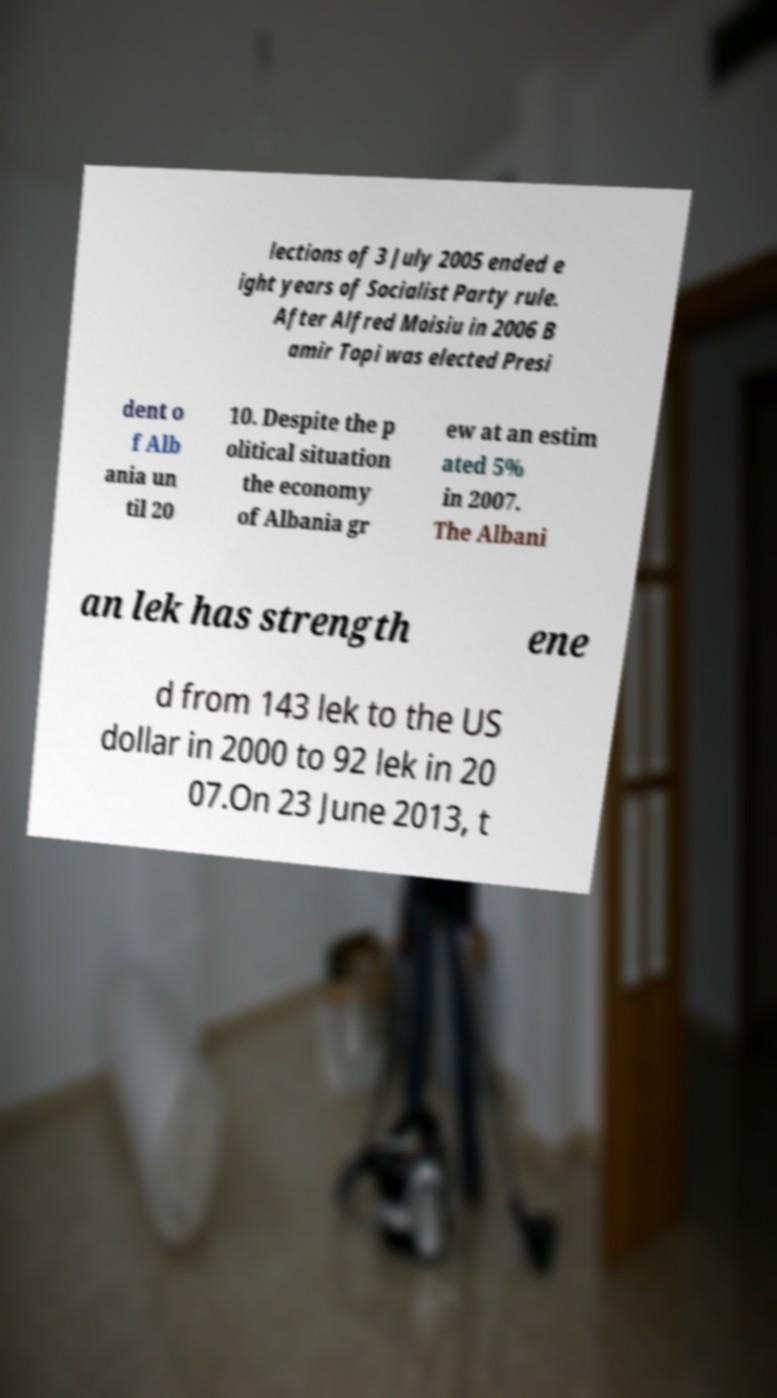Please identify and transcribe the text found in this image. lections of 3 July 2005 ended e ight years of Socialist Party rule. After Alfred Moisiu in 2006 B amir Topi was elected Presi dent o f Alb ania un til 20 10. Despite the p olitical situation the economy of Albania gr ew at an estim ated 5% in 2007. The Albani an lek has strength ene d from 143 lek to the US dollar in 2000 to 92 lek in 20 07.On 23 June 2013, t 